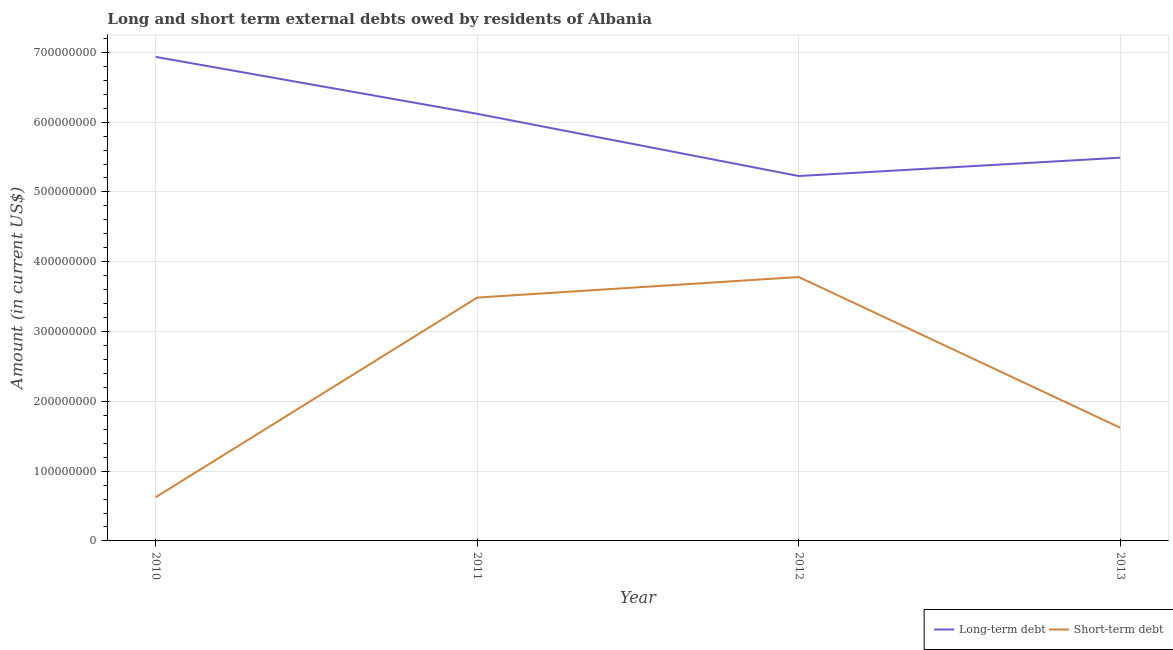Does the line corresponding to long-term debts owed by residents intersect with the line corresponding to short-term debts owed by residents?
Offer a terse response. No. What is the long-term debts owed by residents in 2011?
Ensure brevity in your answer.  6.12e+08. Across all years, what is the maximum short-term debts owed by residents?
Offer a very short reply. 3.78e+08. Across all years, what is the minimum short-term debts owed by residents?
Make the answer very short. 6.26e+07. In which year was the long-term debts owed by residents maximum?
Make the answer very short. 2010. In which year was the long-term debts owed by residents minimum?
Your response must be concise. 2012. What is the total short-term debts owed by residents in the graph?
Your response must be concise. 9.51e+08. What is the difference between the short-term debts owed by residents in 2010 and that in 2012?
Offer a very short reply. -3.15e+08. What is the difference between the short-term debts owed by residents in 2011 and the long-term debts owed by residents in 2013?
Give a very brief answer. -2.00e+08. What is the average short-term debts owed by residents per year?
Provide a short and direct response. 2.38e+08. In the year 2010, what is the difference between the short-term debts owed by residents and long-term debts owed by residents?
Give a very brief answer. -6.31e+08. In how many years, is the short-term debts owed by residents greater than 320000000 US$?
Offer a terse response. 2. What is the ratio of the short-term debts owed by residents in 2012 to that in 2013?
Your answer should be very brief. 2.33. Is the difference between the short-term debts owed by residents in 2012 and 2013 greater than the difference between the long-term debts owed by residents in 2012 and 2013?
Keep it short and to the point. Yes. What is the difference between the highest and the second highest long-term debts owed by residents?
Your answer should be very brief. 8.15e+07. What is the difference between the highest and the lowest short-term debts owed by residents?
Ensure brevity in your answer.  3.15e+08. In how many years, is the long-term debts owed by residents greater than the average long-term debts owed by residents taken over all years?
Make the answer very short. 2. Does the short-term debts owed by residents monotonically increase over the years?
Your answer should be very brief. No. Is the long-term debts owed by residents strictly greater than the short-term debts owed by residents over the years?
Make the answer very short. Yes. How many lines are there?
Keep it short and to the point. 2. How many years are there in the graph?
Offer a terse response. 4. Are the values on the major ticks of Y-axis written in scientific E-notation?
Offer a very short reply. No. Does the graph contain any zero values?
Offer a very short reply. No. Does the graph contain grids?
Your answer should be compact. Yes. How are the legend labels stacked?
Keep it short and to the point. Horizontal. What is the title of the graph?
Keep it short and to the point. Long and short term external debts owed by residents of Albania. What is the Amount (in current US$) of Long-term debt in 2010?
Provide a short and direct response. 6.93e+08. What is the Amount (in current US$) of Short-term debt in 2010?
Provide a succinct answer. 6.26e+07. What is the Amount (in current US$) of Long-term debt in 2011?
Your answer should be very brief. 6.12e+08. What is the Amount (in current US$) of Short-term debt in 2011?
Offer a very short reply. 3.49e+08. What is the Amount (in current US$) in Long-term debt in 2012?
Your answer should be compact. 5.23e+08. What is the Amount (in current US$) in Short-term debt in 2012?
Your response must be concise. 3.78e+08. What is the Amount (in current US$) in Long-term debt in 2013?
Your response must be concise. 5.49e+08. What is the Amount (in current US$) of Short-term debt in 2013?
Ensure brevity in your answer.  1.62e+08. Across all years, what is the maximum Amount (in current US$) of Long-term debt?
Offer a terse response. 6.93e+08. Across all years, what is the maximum Amount (in current US$) of Short-term debt?
Your answer should be very brief. 3.78e+08. Across all years, what is the minimum Amount (in current US$) in Long-term debt?
Your answer should be compact. 5.23e+08. Across all years, what is the minimum Amount (in current US$) of Short-term debt?
Keep it short and to the point. 6.26e+07. What is the total Amount (in current US$) in Long-term debt in the graph?
Your answer should be compact. 2.38e+09. What is the total Amount (in current US$) in Short-term debt in the graph?
Give a very brief answer. 9.51e+08. What is the difference between the Amount (in current US$) in Long-term debt in 2010 and that in 2011?
Your answer should be very brief. 8.15e+07. What is the difference between the Amount (in current US$) of Short-term debt in 2010 and that in 2011?
Offer a terse response. -2.86e+08. What is the difference between the Amount (in current US$) of Long-term debt in 2010 and that in 2012?
Provide a succinct answer. 1.71e+08. What is the difference between the Amount (in current US$) of Short-term debt in 2010 and that in 2012?
Your answer should be compact. -3.15e+08. What is the difference between the Amount (in current US$) in Long-term debt in 2010 and that in 2013?
Give a very brief answer. 1.44e+08. What is the difference between the Amount (in current US$) in Short-term debt in 2010 and that in 2013?
Ensure brevity in your answer.  -9.95e+07. What is the difference between the Amount (in current US$) of Long-term debt in 2011 and that in 2012?
Offer a terse response. 8.91e+07. What is the difference between the Amount (in current US$) of Short-term debt in 2011 and that in 2012?
Offer a very short reply. -2.95e+07. What is the difference between the Amount (in current US$) in Long-term debt in 2011 and that in 2013?
Offer a very short reply. 6.29e+07. What is the difference between the Amount (in current US$) in Short-term debt in 2011 and that in 2013?
Provide a short and direct response. 1.86e+08. What is the difference between the Amount (in current US$) in Long-term debt in 2012 and that in 2013?
Give a very brief answer. -2.63e+07. What is the difference between the Amount (in current US$) of Short-term debt in 2012 and that in 2013?
Keep it short and to the point. 2.16e+08. What is the difference between the Amount (in current US$) in Long-term debt in 2010 and the Amount (in current US$) in Short-term debt in 2011?
Provide a succinct answer. 3.45e+08. What is the difference between the Amount (in current US$) in Long-term debt in 2010 and the Amount (in current US$) in Short-term debt in 2012?
Your answer should be compact. 3.15e+08. What is the difference between the Amount (in current US$) in Long-term debt in 2010 and the Amount (in current US$) in Short-term debt in 2013?
Offer a very short reply. 5.31e+08. What is the difference between the Amount (in current US$) in Long-term debt in 2011 and the Amount (in current US$) in Short-term debt in 2012?
Your answer should be compact. 2.34e+08. What is the difference between the Amount (in current US$) of Long-term debt in 2011 and the Amount (in current US$) of Short-term debt in 2013?
Keep it short and to the point. 4.50e+08. What is the difference between the Amount (in current US$) of Long-term debt in 2012 and the Amount (in current US$) of Short-term debt in 2013?
Make the answer very short. 3.61e+08. What is the average Amount (in current US$) of Long-term debt per year?
Provide a succinct answer. 5.94e+08. What is the average Amount (in current US$) of Short-term debt per year?
Give a very brief answer. 2.38e+08. In the year 2010, what is the difference between the Amount (in current US$) in Long-term debt and Amount (in current US$) in Short-term debt?
Keep it short and to the point. 6.31e+08. In the year 2011, what is the difference between the Amount (in current US$) in Long-term debt and Amount (in current US$) in Short-term debt?
Provide a succinct answer. 2.63e+08. In the year 2012, what is the difference between the Amount (in current US$) in Long-term debt and Amount (in current US$) in Short-term debt?
Provide a succinct answer. 1.45e+08. In the year 2013, what is the difference between the Amount (in current US$) of Long-term debt and Amount (in current US$) of Short-term debt?
Make the answer very short. 3.87e+08. What is the ratio of the Amount (in current US$) in Long-term debt in 2010 to that in 2011?
Your answer should be compact. 1.13. What is the ratio of the Amount (in current US$) of Short-term debt in 2010 to that in 2011?
Keep it short and to the point. 0.18. What is the ratio of the Amount (in current US$) in Long-term debt in 2010 to that in 2012?
Your answer should be very brief. 1.33. What is the ratio of the Amount (in current US$) of Short-term debt in 2010 to that in 2012?
Provide a short and direct response. 0.17. What is the ratio of the Amount (in current US$) in Long-term debt in 2010 to that in 2013?
Ensure brevity in your answer.  1.26. What is the ratio of the Amount (in current US$) of Short-term debt in 2010 to that in 2013?
Provide a short and direct response. 0.39. What is the ratio of the Amount (in current US$) in Long-term debt in 2011 to that in 2012?
Provide a short and direct response. 1.17. What is the ratio of the Amount (in current US$) of Short-term debt in 2011 to that in 2012?
Your answer should be compact. 0.92. What is the ratio of the Amount (in current US$) of Long-term debt in 2011 to that in 2013?
Ensure brevity in your answer.  1.11. What is the ratio of the Amount (in current US$) in Short-term debt in 2011 to that in 2013?
Your answer should be compact. 2.15. What is the ratio of the Amount (in current US$) of Long-term debt in 2012 to that in 2013?
Your response must be concise. 0.95. What is the ratio of the Amount (in current US$) of Short-term debt in 2012 to that in 2013?
Ensure brevity in your answer.  2.33. What is the difference between the highest and the second highest Amount (in current US$) of Long-term debt?
Your answer should be very brief. 8.15e+07. What is the difference between the highest and the second highest Amount (in current US$) of Short-term debt?
Provide a succinct answer. 2.95e+07. What is the difference between the highest and the lowest Amount (in current US$) of Long-term debt?
Keep it short and to the point. 1.71e+08. What is the difference between the highest and the lowest Amount (in current US$) of Short-term debt?
Your answer should be very brief. 3.15e+08. 